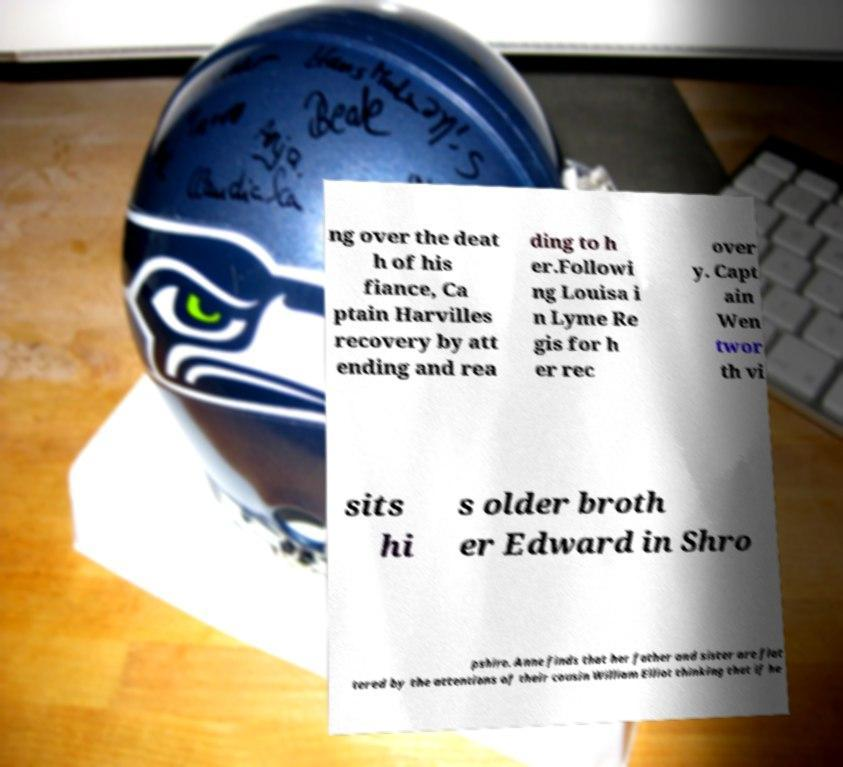What messages or text are displayed in this image? I need them in a readable, typed format. ng over the deat h of his fiance, Ca ptain Harvilles recovery by att ending and rea ding to h er.Followi ng Louisa i n Lyme Re gis for h er rec over y. Capt ain Wen twor th vi sits hi s older broth er Edward in Shro pshire. Anne finds that her father and sister are flat tered by the attentions of their cousin William Elliot thinking that if he 